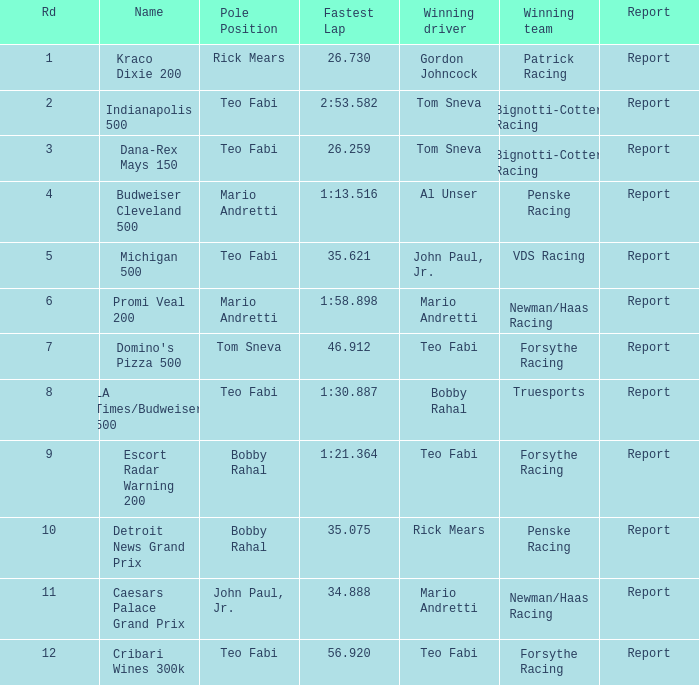In the race where forsythe racing emerged victorious and teo fabi secured the pole position, how many reports exist? 1.0. 